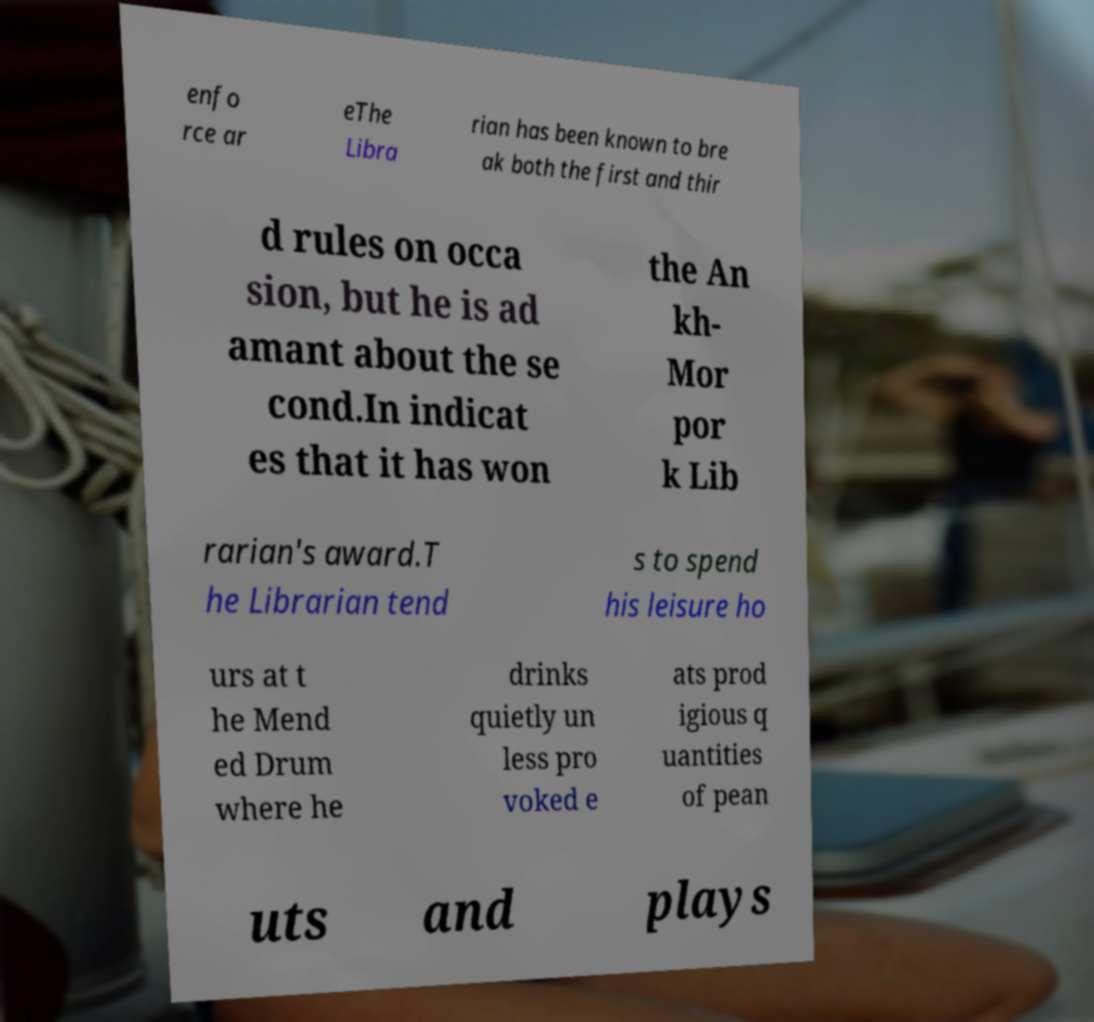Please read and relay the text visible in this image. What does it say? enfo rce ar eThe Libra rian has been known to bre ak both the first and thir d rules on occa sion, but he is ad amant about the se cond.In indicat es that it has won the An kh- Mor por k Lib rarian's award.T he Librarian tend s to spend his leisure ho urs at t he Mend ed Drum where he drinks quietly un less pro voked e ats prod igious q uantities of pean uts and plays 